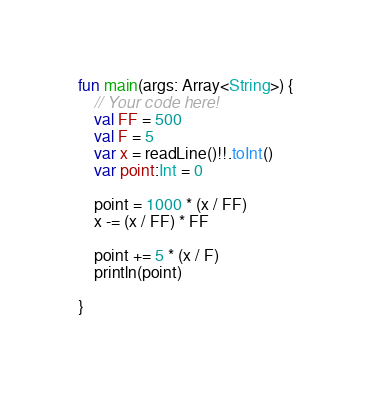Convert code to text. <code><loc_0><loc_0><loc_500><loc_500><_Kotlin_>fun main(args: Array<String>) {
    // Your code here!
    val FF = 500
    val F = 5
    var x = readLine()!!.toInt()
    var point:Int = 0
    
    point = 1000 * (x / FF) 
    x -= (x / FF) * FF
    
    point += 5 * (x / F)
    println(point)
    
}
</code> 